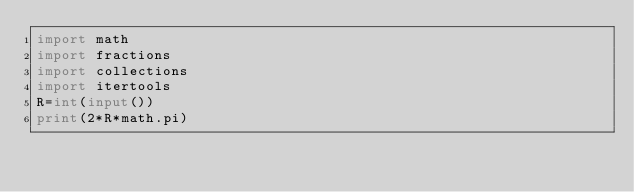Convert code to text. <code><loc_0><loc_0><loc_500><loc_500><_Python_>import math
import fractions
import collections
import itertools
R=int(input())
print(2*R*math.pi)</code> 